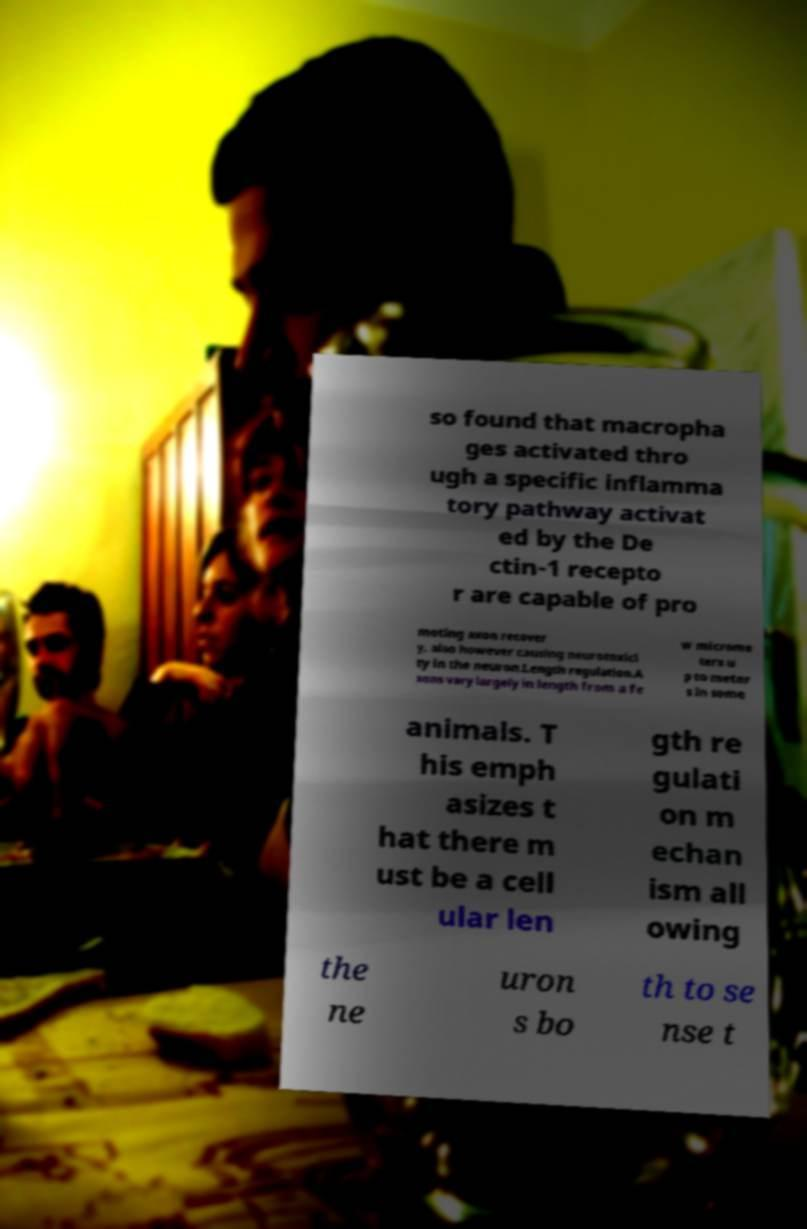Please identify and transcribe the text found in this image. so found that macropha ges activated thro ugh a specific inflamma tory pathway activat ed by the De ctin-1 recepto r are capable of pro moting axon recover y, also however causing neurotoxici ty in the neuron.Length regulation.A xons vary largely in length from a fe w microme ters u p to meter s in some animals. T his emph asizes t hat there m ust be a cell ular len gth re gulati on m echan ism all owing the ne uron s bo th to se nse t 